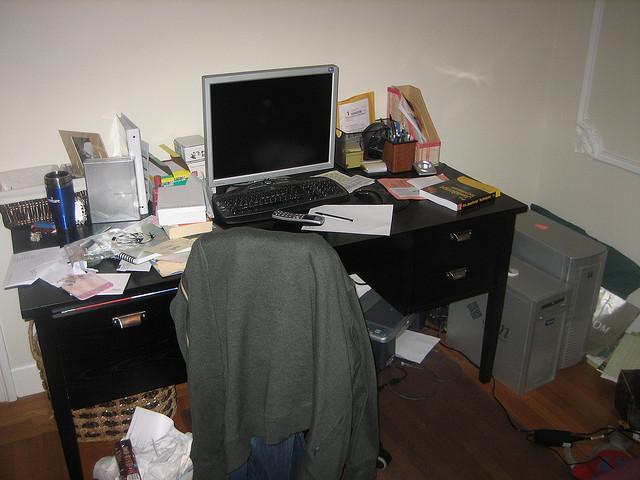How many computer towers are in the picture?
Give a very brief answer. 2. 